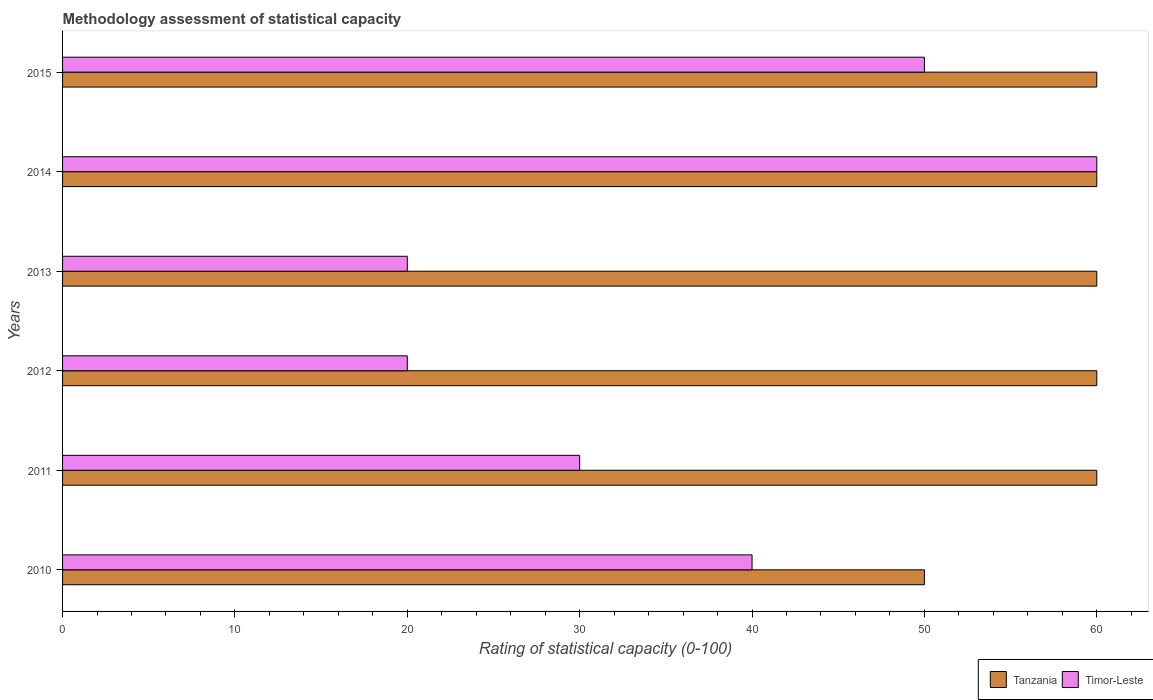How many different coloured bars are there?
Provide a succinct answer. 2. How many groups of bars are there?
Provide a short and direct response. 6. Are the number of bars per tick equal to the number of legend labels?
Ensure brevity in your answer.  Yes. How many bars are there on the 6th tick from the top?
Provide a short and direct response. 2. What is the rating of statistical capacity in Tanzania in 2014?
Give a very brief answer. 60. Across all years, what is the minimum rating of statistical capacity in Tanzania?
Your answer should be compact. 50. What is the total rating of statistical capacity in Tanzania in the graph?
Offer a very short reply. 350. What is the difference between the rating of statistical capacity in Timor-Leste in 2013 and that in 2014?
Provide a short and direct response. -40. What is the average rating of statistical capacity in Timor-Leste per year?
Your answer should be compact. 36.67. What is the ratio of the rating of statistical capacity in Timor-Leste in 2012 to that in 2014?
Your answer should be compact. 0.33. Is the rating of statistical capacity in Timor-Leste in 2010 less than that in 2015?
Your answer should be very brief. Yes. What is the difference between the highest and the second highest rating of statistical capacity in Timor-Leste?
Provide a short and direct response. 10. Is the sum of the rating of statistical capacity in Timor-Leste in 2012 and 2015 greater than the maximum rating of statistical capacity in Tanzania across all years?
Keep it short and to the point. Yes. What does the 1st bar from the top in 2014 represents?
Offer a very short reply. Timor-Leste. What does the 2nd bar from the bottom in 2011 represents?
Ensure brevity in your answer.  Timor-Leste. How many bars are there?
Keep it short and to the point. 12. How many years are there in the graph?
Provide a succinct answer. 6. Are the values on the major ticks of X-axis written in scientific E-notation?
Make the answer very short. No. Does the graph contain any zero values?
Provide a short and direct response. No. Does the graph contain grids?
Ensure brevity in your answer.  No. How are the legend labels stacked?
Your answer should be very brief. Horizontal. What is the title of the graph?
Offer a very short reply. Methodology assessment of statistical capacity. What is the label or title of the X-axis?
Make the answer very short. Rating of statistical capacity (0-100). What is the Rating of statistical capacity (0-100) in Timor-Leste in 2010?
Provide a short and direct response. 40. What is the Rating of statistical capacity (0-100) in Tanzania in 2011?
Make the answer very short. 60. What is the Rating of statistical capacity (0-100) in Timor-Leste in 2011?
Offer a very short reply. 30. What is the Rating of statistical capacity (0-100) of Tanzania in 2012?
Keep it short and to the point. 60. What is the Rating of statistical capacity (0-100) of Timor-Leste in 2012?
Give a very brief answer. 20. What is the Rating of statistical capacity (0-100) in Timor-Leste in 2013?
Give a very brief answer. 20. What is the Rating of statistical capacity (0-100) in Timor-Leste in 2014?
Give a very brief answer. 60. What is the Rating of statistical capacity (0-100) of Tanzania in 2015?
Keep it short and to the point. 60. What is the Rating of statistical capacity (0-100) in Timor-Leste in 2015?
Your answer should be compact. 50. Across all years, what is the minimum Rating of statistical capacity (0-100) of Tanzania?
Ensure brevity in your answer.  50. What is the total Rating of statistical capacity (0-100) of Tanzania in the graph?
Make the answer very short. 350. What is the total Rating of statistical capacity (0-100) in Timor-Leste in the graph?
Keep it short and to the point. 220. What is the difference between the Rating of statistical capacity (0-100) of Timor-Leste in 2010 and that in 2011?
Your response must be concise. 10. What is the difference between the Rating of statistical capacity (0-100) of Timor-Leste in 2010 and that in 2013?
Your answer should be very brief. 20. What is the difference between the Rating of statistical capacity (0-100) of Tanzania in 2010 and that in 2014?
Your answer should be compact. -10. What is the difference between the Rating of statistical capacity (0-100) in Timor-Leste in 2010 and that in 2014?
Give a very brief answer. -20. What is the difference between the Rating of statistical capacity (0-100) in Tanzania in 2011 and that in 2012?
Offer a terse response. 0. What is the difference between the Rating of statistical capacity (0-100) of Timor-Leste in 2011 and that in 2012?
Keep it short and to the point. 10. What is the difference between the Rating of statistical capacity (0-100) of Timor-Leste in 2011 and that in 2013?
Give a very brief answer. 10. What is the difference between the Rating of statistical capacity (0-100) of Timor-Leste in 2011 and that in 2014?
Provide a succinct answer. -30. What is the difference between the Rating of statistical capacity (0-100) in Tanzania in 2012 and that in 2013?
Offer a terse response. 0. What is the difference between the Rating of statistical capacity (0-100) of Timor-Leste in 2012 and that in 2013?
Provide a short and direct response. 0. What is the difference between the Rating of statistical capacity (0-100) in Tanzania in 2012 and that in 2014?
Your answer should be very brief. 0. What is the difference between the Rating of statistical capacity (0-100) of Timor-Leste in 2013 and that in 2014?
Offer a terse response. -40. What is the difference between the Rating of statistical capacity (0-100) in Tanzania in 2013 and that in 2015?
Provide a short and direct response. 0. What is the difference between the Rating of statistical capacity (0-100) in Tanzania in 2010 and the Rating of statistical capacity (0-100) in Timor-Leste in 2012?
Offer a very short reply. 30. What is the difference between the Rating of statistical capacity (0-100) of Tanzania in 2010 and the Rating of statistical capacity (0-100) of Timor-Leste in 2013?
Keep it short and to the point. 30. What is the difference between the Rating of statistical capacity (0-100) in Tanzania in 2010 and the Rating of statistical capacity (0-100) in Timor-Leste in 2014?
Ensure brevity in your answer.  -10. What is the difference between the Rating of statistical capacity (0-100) of Tanzania in 2010 and the Rating of statistical capacity (0-100) of Timor-Leste in 2015?
Your answer should be compact. 0. What is the difference between the Rating of statistical capacity (0-100) in Tanzania in 2011 and the Rating of statistical capacity (0-100) in Timor-Leste in 2012?
Give a very brief answer. 40. What is the difference between the Rating of statistical capacity (0-100) in Tanzania in 2012 and the Rating of statistical capacity (0-100) in Timor-Leste in 2013?
Offer a terse response. 40. What is the difference between the Rating of statistical capacity (0-100) of Tanzania in 2012 and the Rating of statistical capacity (0-100) of Timor-Leste in 2015?
Offer a very short reply. 10. What is the difference between the Rating of statistical capacity (0-100) in Tanzania in 2013 and the Rating of statistical capacity (0-100) in Timor-Leste in 2015?
Make the answer very short. 10. What is the difference between the Rating of statistical capacity (0-100) in Tanzania in 2014 and the Rating of statistical capacity (0-100) in Timor-Leste in 2015?
Offer a very short reply. 10. What is the average Rating of statistical capacity (0-100) in Tanzania per year?
Your response must be concise. 58.33. What is the average Rating of statistical capacity (0-100) in Timor-Leste per year?
Make the answer very short. 36.67. In the year 2011, what is the difference between the Rating of statistical capacity (0-100) in Tanzania and Rating of statistical capacity (0-100) in Timor-Leste?
Offer a terse response. 30. What is the ratio of the Rating of statistical capacity (0-100) in Tanzania in 2010 to that in 2011?
Ensure brevity in your answer.  0.83. What is the ratio of the Rating of statistical capacity (0-100) in Timor-Leste in 2010 to that in 2012?
Ensure brevity in your answer.  2. What is the ratio of the Rating of statistical capacity (0-100) of Timor-Leste in 2010 to that in 2014?
Your answer should be very brief. 0.67. What is the ratio of the Rating of statistical capacity (0-100) of Timor-Leste in 2010 to that in 2015?
Make the answer very short. 0.8. What is the ratio of the Rating of statistical capacity (0-100) of Tanzania in 2011 to that in 2012?
Give a very brief answer. 1. What is the ratio of the Rating of statistical capacity (0-100) of Timor-Leste in 2011 to that in 2012?
Offer a terse response. 1.5. What is the ratio of the Rating of statistical capacity (0-100) in Tanzania in 2011 to that in 2014?
Offer a terse response. 1. What is the ratio of the Rating of statistical capacity (0-100) in Timor-Leste in 2011 to that in 2014?
Provide a short and direct response. 0.5. What is the ratio of the Rating of statistical capacity (0-100) in Tanzania in 2011 to that in 2015?
Ensure brevity in your answer.  1. What is the ratio of the Rating of statistical capacity (0-100) in Tanzania in 2012 to that in 2014?
Make the answer very short. 1. What is the ratio of the Rating of statistical capacity (0-100) of Timor-Leste in 2012 to that in 2015?
Your response must be concise. 0.4. What is the ratio of the Rating of statistical capacity (0-100) of Tanzania in 2013 to that in 2014?
Offer a very short reply. 1. What is the ratio of the Rating of statistical capacity (0-100) in Timor-Leste in 2013 to that in 2015?
Ensure brevity in your answer.  0.4. What is the ratio of the Rating of statistical capacity (0-100) in Tanzania in 2014 to that in 2015?
Offer a terse response. 1. What is the ratio of the Rating of statistical capacity (0-100) in Timor-Leste in 2014 to that in 2015?
Provide a succinct answer. 1.2. What is the difference between the highest and the lowest Rating of statistical capacity (0-100) of Tanzania?
Offer a terse response. 10. What is the difference between the highest and the lowest Rating of statistical capacity (0-100) of Timor-Leste?
Your response must be concise. 40. 